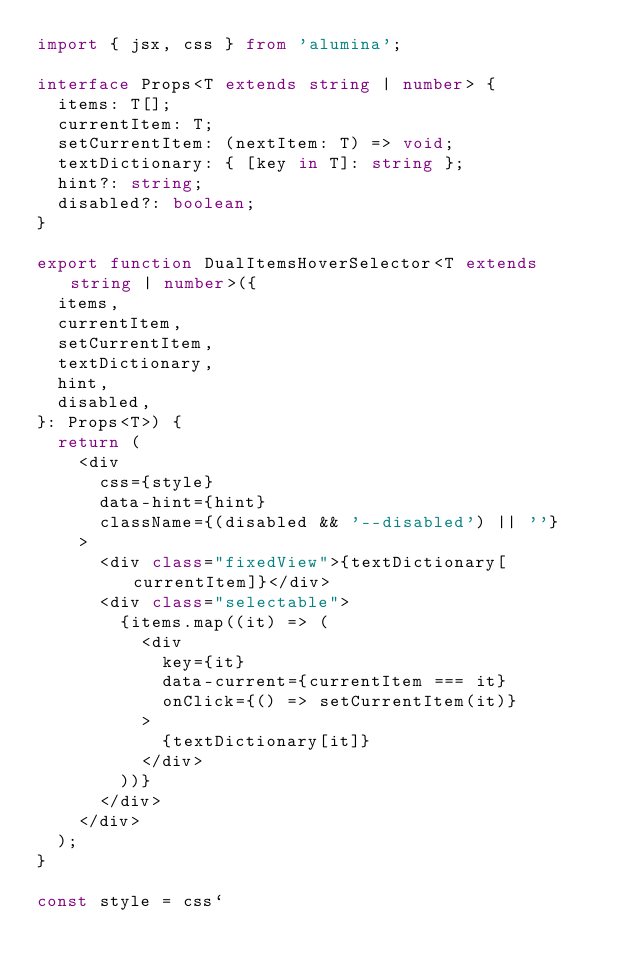Convert code to text. <code><loc_0><loc_0><loc_500><loc_500><_TypeScript_>import { jsx, css } from 'alumina';

interface Props<T extends string | number> {
  items: T[];
  currentItem: T;
  setCurrentItem: (nextItem: T) => void;
  textDictionary: { [key in T]: string };
  hint?: string;
  disabled?: boolean;
}

export function DualItemsHoverSelector<T extends string | number>({
  items,
  currentItem,
  setCurrentItem,
  textDictionary,
  hint,
  disabled,
}: Props<T>) {
  return (
    <div
      css={style}
      data-hint={hint}
      className={(disabled && '--disabled') || ''}
    >
      <div class="fixedView">{textDictionary[currentItem]}</div>
      <div class="selectable">
        {items.map((it) => (
          <div
            key={it}
            data-current={currentItem === it}
            onClick={() => setCurrentItem(it)}
          >
            {textDictionary[it]}
          </div>
        ))}
      </div>
    </div>
  );
}

const style = css`</code> 